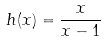<formula> <loc_0><loc_0><loc_500><loc_500>h ( x ) = \frac { x } { x - 1 }</formula> 